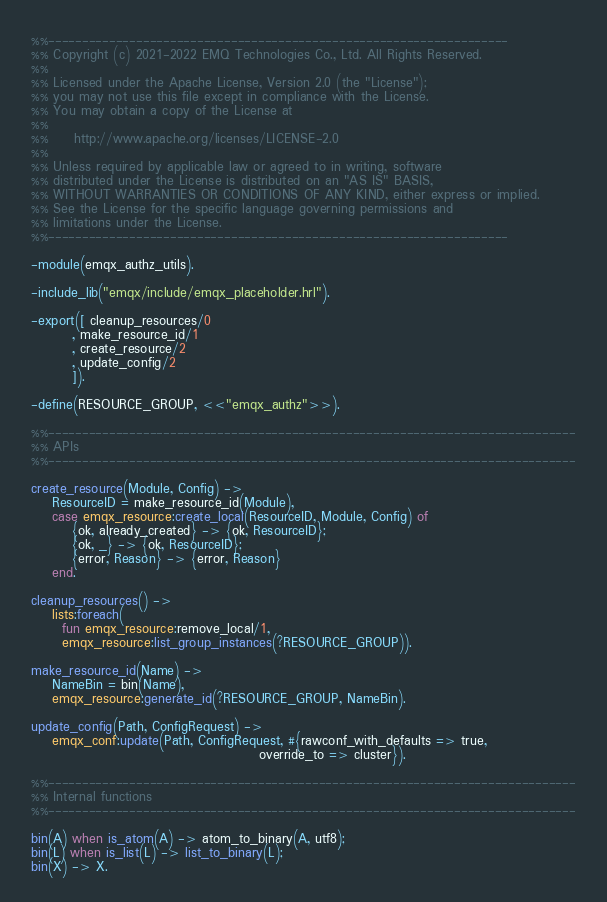Convert code to text. <code><loc_0><loc_0><loc_500><loc_500><_Erlang_>%%--------------------------------------------------------------------
%% Copyright (c) 2021-2022 EMQ Technologies Co., Ltd. All Rights Reserved.
%%
%% Licensed under the Apache License, Version 2.0 (the "License");
%% you may not use this file except in compliance with the License.
%% You may obtain a copy of the License at
%%
%%     http://www.apache.org/licenses/LICENSE-2.0
%%
%% Unless required by applicable law or agreed to in writing, software
%% distributed under the License is distributed on an "AS IS" BASIS,
%% WITHOUT WARRANTIES OR CONDITIONS OF ANY KIND, either express or implied.
%% See the License for the specific language governing permissions and
%% limitations under the License.
%%--------------------------------------------------------------------

-module(emqx_authz_utils).

-include_lib("emqx/include/emqx_placeholder.hrl").

-export([ cleanup_resources/0
        , make_resource_id/1
        , create_resource/2
        , update_config/2
        ]).

-define(RESOURCE_GROUP, <<"emqx_authz">>).

%%------------------------------------------------------------------------------
%% APIs
%%------------------------------------------------------------------------------

create_resource(Module, Config) ->
    ResourceID = make_resource_id(Module),
    case emqx_resource:create_local(ResourceID, Module, Config) of
        {ok, already_created} -> {ok, ResourceID};
        {ok, _} -> {ok, ResourceID};
        {error, Reason} -> {error, Reason}
    end.

cleanup_resources() ->
    lists:foreach(
      fun emqx_resource:remove_local/1,
      emqx_resource:list_group_instances(?RESOURCE_GROUP)).

make_resource_id(Name) ->
    NameBin = bin(Name),
    emqx_resource:generate_id(?RESOURCE_GROUP, NameBin).

update_config(Path, ConfigRequest) ->
    emqx_conf:update(Path, ConfigRequest, #{rawconf_with_defaults => true,
                                            override_to => cluster}).

%%------------------------------------------------------------------------------
%% Internal functions
%%------------------------------------------------------------------------------

bin(A) when is_atom(A) -> atom_to_binary(A, utf8);
bin(L) when is_list(L) -> list_to_binary(L);
bin(X) -> X.
</code> 